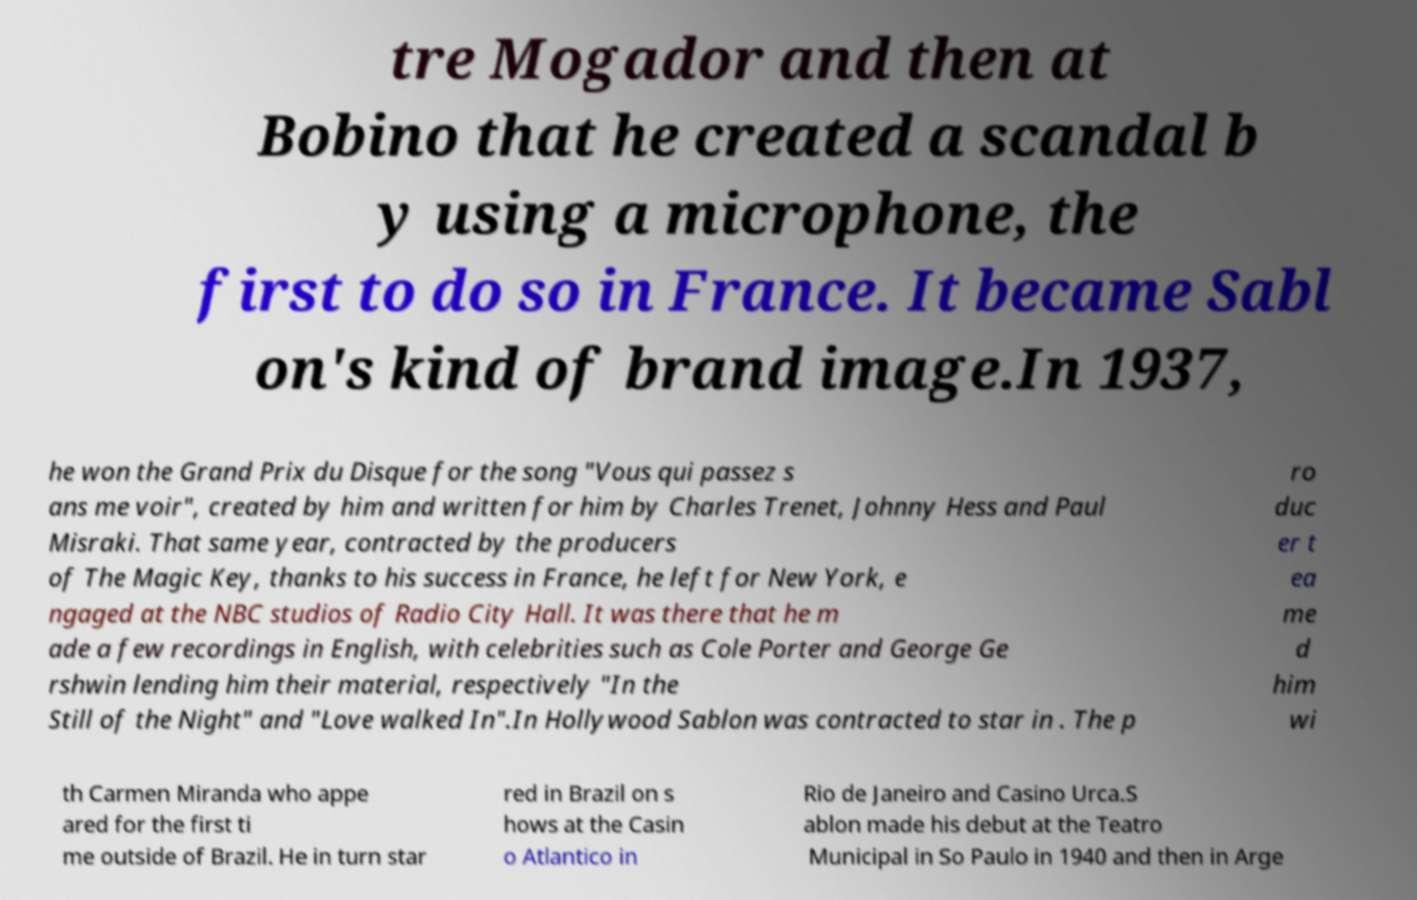I need the written content from this picture converted into text. Can you do that? tre Mogador and then at Bobino that he created a scandal b y using a microphone, the first to do so in France. It became Sabl on's kind of brand image.In 1937, he won the Grand Prix du Disque for the song "Vous qui passez s ans me voir", created by him and written for him by Charles Trenet, Johnny Hess and Paul Misraki. That same year, contracted by the producers of The Magic Key, thanks to his success in France, he left for New York, e ngaged at the NBC studios of Radio City Hall. It was there that he m ade a few recordings in English, with celebrities such as Cole Porter and George Ge rshwin lending him their material, respectively "In the Still of the Night" and "Love walked In".In Hollywood Sablon was contracted to star in . The p ro duc er t ea me d him wi th Carmen Miranda who appe ared for the first ti me outside of Brazil. He in turn star red in Brazil on s hows at the Casin o Atlantico in Rio de Janeiro and Casino Urca.S ablon made his debut at the Teatro Municipal in So Paulo in 1940 and then in Arge 